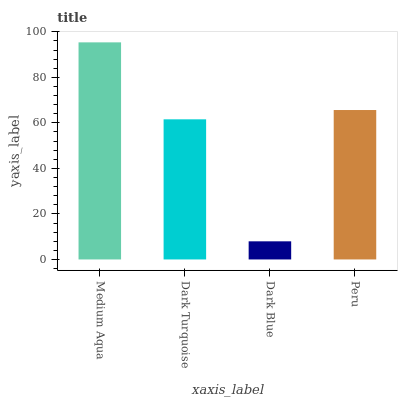Is Dark Blue the minimum?
Answer yes or no. Yes. Is Medium Aqua the maximum?
Answer yes or no. Yes. Is Dark Turquoise the minimum?
Answer yes or no. No. Is Dark Turquoise the maximum?
Answer yes or no. No. Is Medium Aqua greater than Dark Turquoise?
Answer yes or no. Yes. Is Dark Turquoise less than Medium Aqua?
Answer yes or no. Yes. Is Dark Turquoise greater than Medium Aqua?
Answer yes or no. No. Is Medium Aqua less than Dark Turquoise?
Answer yes or no. No. Is Peru the high median?
Answer yes or no. Yes. Is Dark Turquoise the low median?
Answer yes or no. Yes. Is Dark Blue the high median?
Answer yes or no. No. Is Peru the low median?
Answer yes or no. No. 